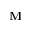<formula> <loc_0><loc_0><loc_500><loc_500>M</formula> 